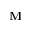<formula> <loc_0><loc_0><loc_500><loc_500>M</formula> 